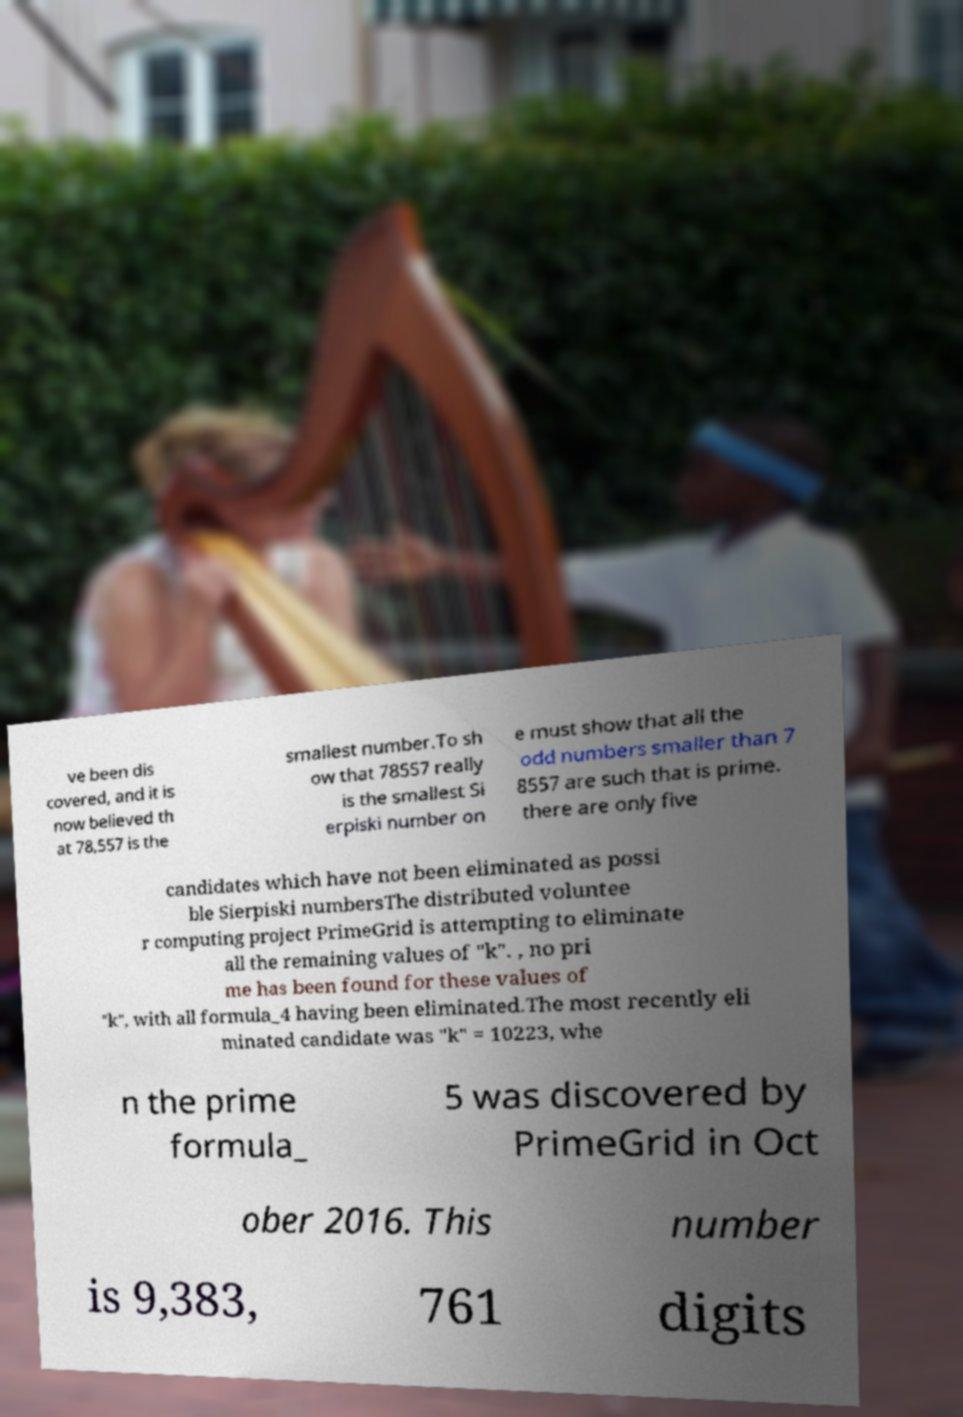For documentation purposes, I need the text within this image transcribed. Could you provide that? ve been dis covered, and it is now believed th at 78,557 is the smallest number.To sh ow that 78557 really is the smallest Si erpiski number on e must show that all the odd numbers smaller than 7 8557 are such that is prime. there are only five candidates which have not been eliminated as possi ble Sierpiski numbersThe distributed voluntee r computing project PrimeGrid is attempting to eliminate all the remaining values of "k". , no pri me has been found for these values of "k", with all formula_4 having been eliminated.The most recently eli minated candidate was "k" = 10223, whe n the prime formula_ 5 was discovered by PrimeGrid in Oct ober 2016. This number is 9,383, 761 digits 